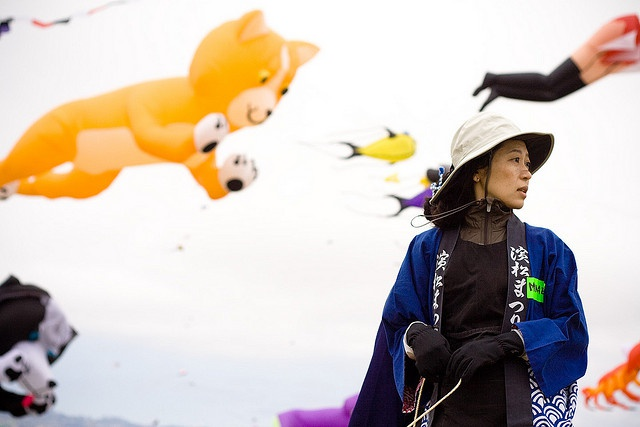Describe the objects in this image and their specific colors. I can see people in lightgray, black, navy, white, and gray tones, kite in lightgray, orange, and white tones, kite in lightgray, black, darkgray, lavender, and gray tones, kite in lightgray, black, lightpink, and salmon tones, and kite in lightgray, red, orange, lightpink, and salmon tones in this image. 